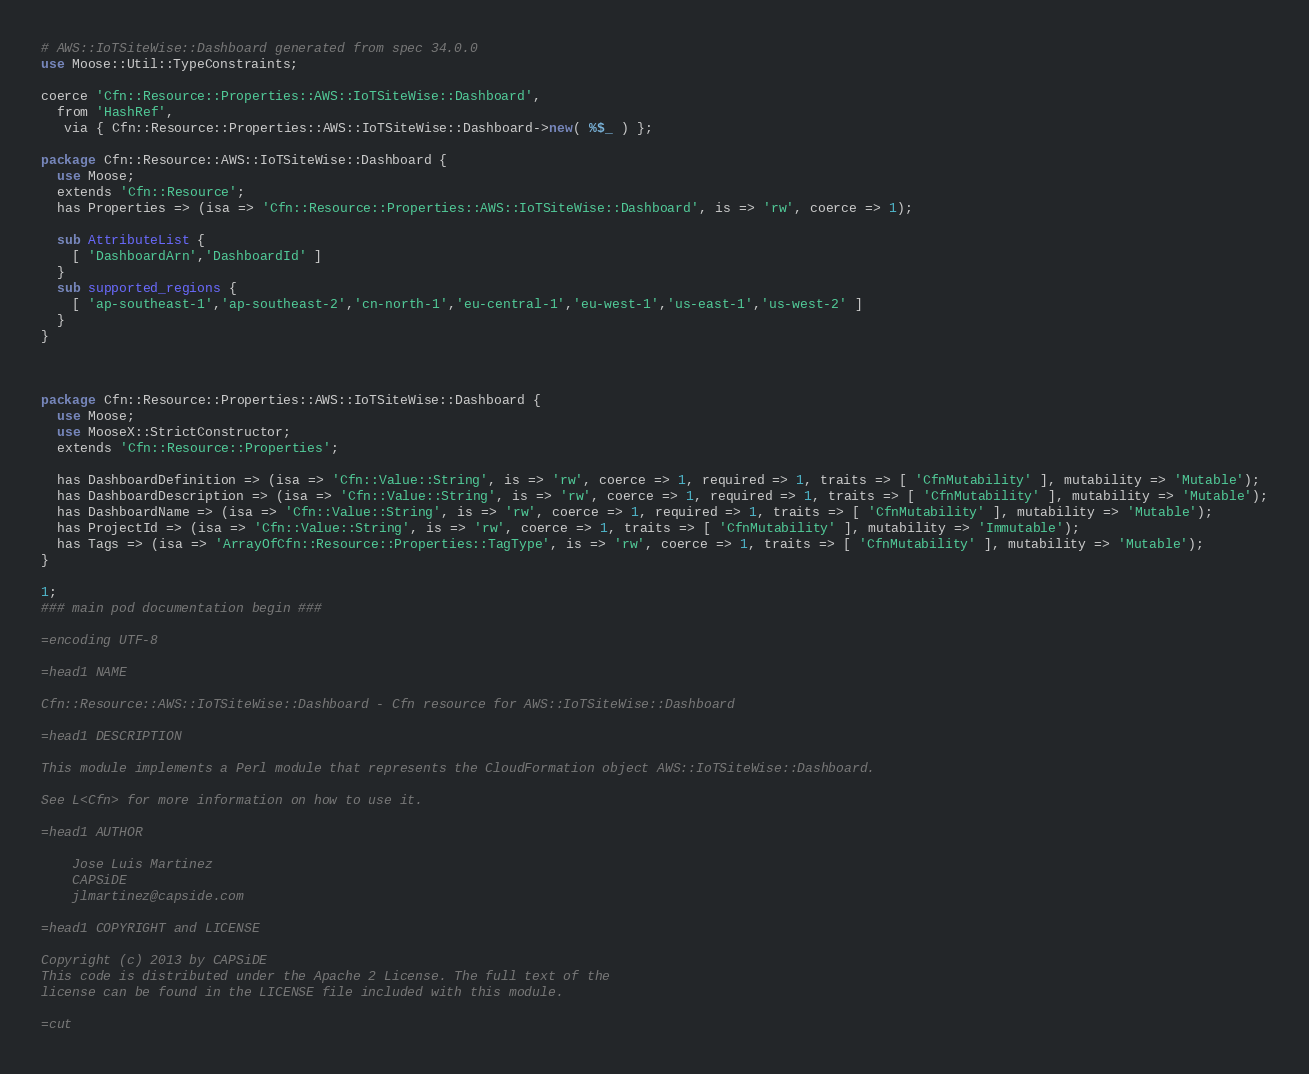<code> <loc_0><loc_0><loc_500><loc_500><_Perl_># AWS::IoTSiteWise::Dashboard generated from spec 34.0.0
use Moose::Util::TypeConstraints;

coerce 'Cfn::Resource::Properties::AWS::IoTSiteWise::Dashboard',
  from 'HashRef',
   via { Cfn::Resource::Properties::AWS::IoTSiteWise::Dashboard->new( %$_ ) };

package Cfn::Resource::AWS::IoTSiteWise::Dashboard {
  use Moose;
  extends 'Cfn::Resource';
  has Properties => (isa => 'Cfn::Resource::Properties::AWS::IoTSiteWise::Dashboard', is => 'rw', coerce => 1);
  
  sub AttributeList {
    [ 'DashboardArn','DashboardId' ]
  }
  sub supported_regions {
    [ 'ap-southeast-1','ap-southeast-2','cn-north-1','eu-central-1','eu-west-1','us-east-1','us-west-2' ]
  }
}



package Cfn::Resource::Properties::AWS::IoTSiteWise::Dashboard {
  use Moose;
  use MooseX::StrictConstructor;
  extends 'Cfn::Resource::Properties';
  
  has DashboardDefinition => (isa => 'Cfn::Value::String', is => 'rw', coerce => 1, required => 1, traits => [ 'CfnMutability' ], mutability => 'Mutable');
  has DashboardDescription => (isa => 'Cfn::Value::String', is => 'rw', coerce => 1, required => 1, traits => [ 'CfnMutability' ], mutability => 'Mutable');
  has DashboardName => (isa => 'Cfn::Value::String', is => 'rw', coerce => 1, required => 1, traits => [ 'CfnMutability' ], mutability => 'Mutable');
  has ProjectId => (isa => 'Cfn::Value::String', is => 'rw', coerce => 1, traits => [ 'CfnMutability' ], mutability => 'Immutable');
  has Tags => (isa => 'ArrayOfCfn::Resource::Properties::TagType', is => 'rw', coerce => 1, traits => [ 'CfnMutability' ], mutability => 'Mutable');
}

1;
### main pod documentation begin ###

=encoding UTF-8

=head1 NAME

Cfn::Resource::AWS::IoTSiteWise::Dashboard - Cfn resource for AWS::IoTSiteWise::Dashboard

=head1 DESCRIPTION

This module implements a Perl module that represents the CloudFormation object AWS::IoTSiteWise::Dashboard.

See L<Cfn> for more information on how to use it.

=head1 AUTHOR

    Jose Luis Martinez
    CAPSiDE
    jlmartinez@capside.com

=head1 COPYRIGHT and LICENSE

Copyright (c) 2013 by CAPSiDE
This code is distributed under the Apache 2 License. The full text of the 
license can be found in the LICENSE file included with this module.

=cut
</code> 